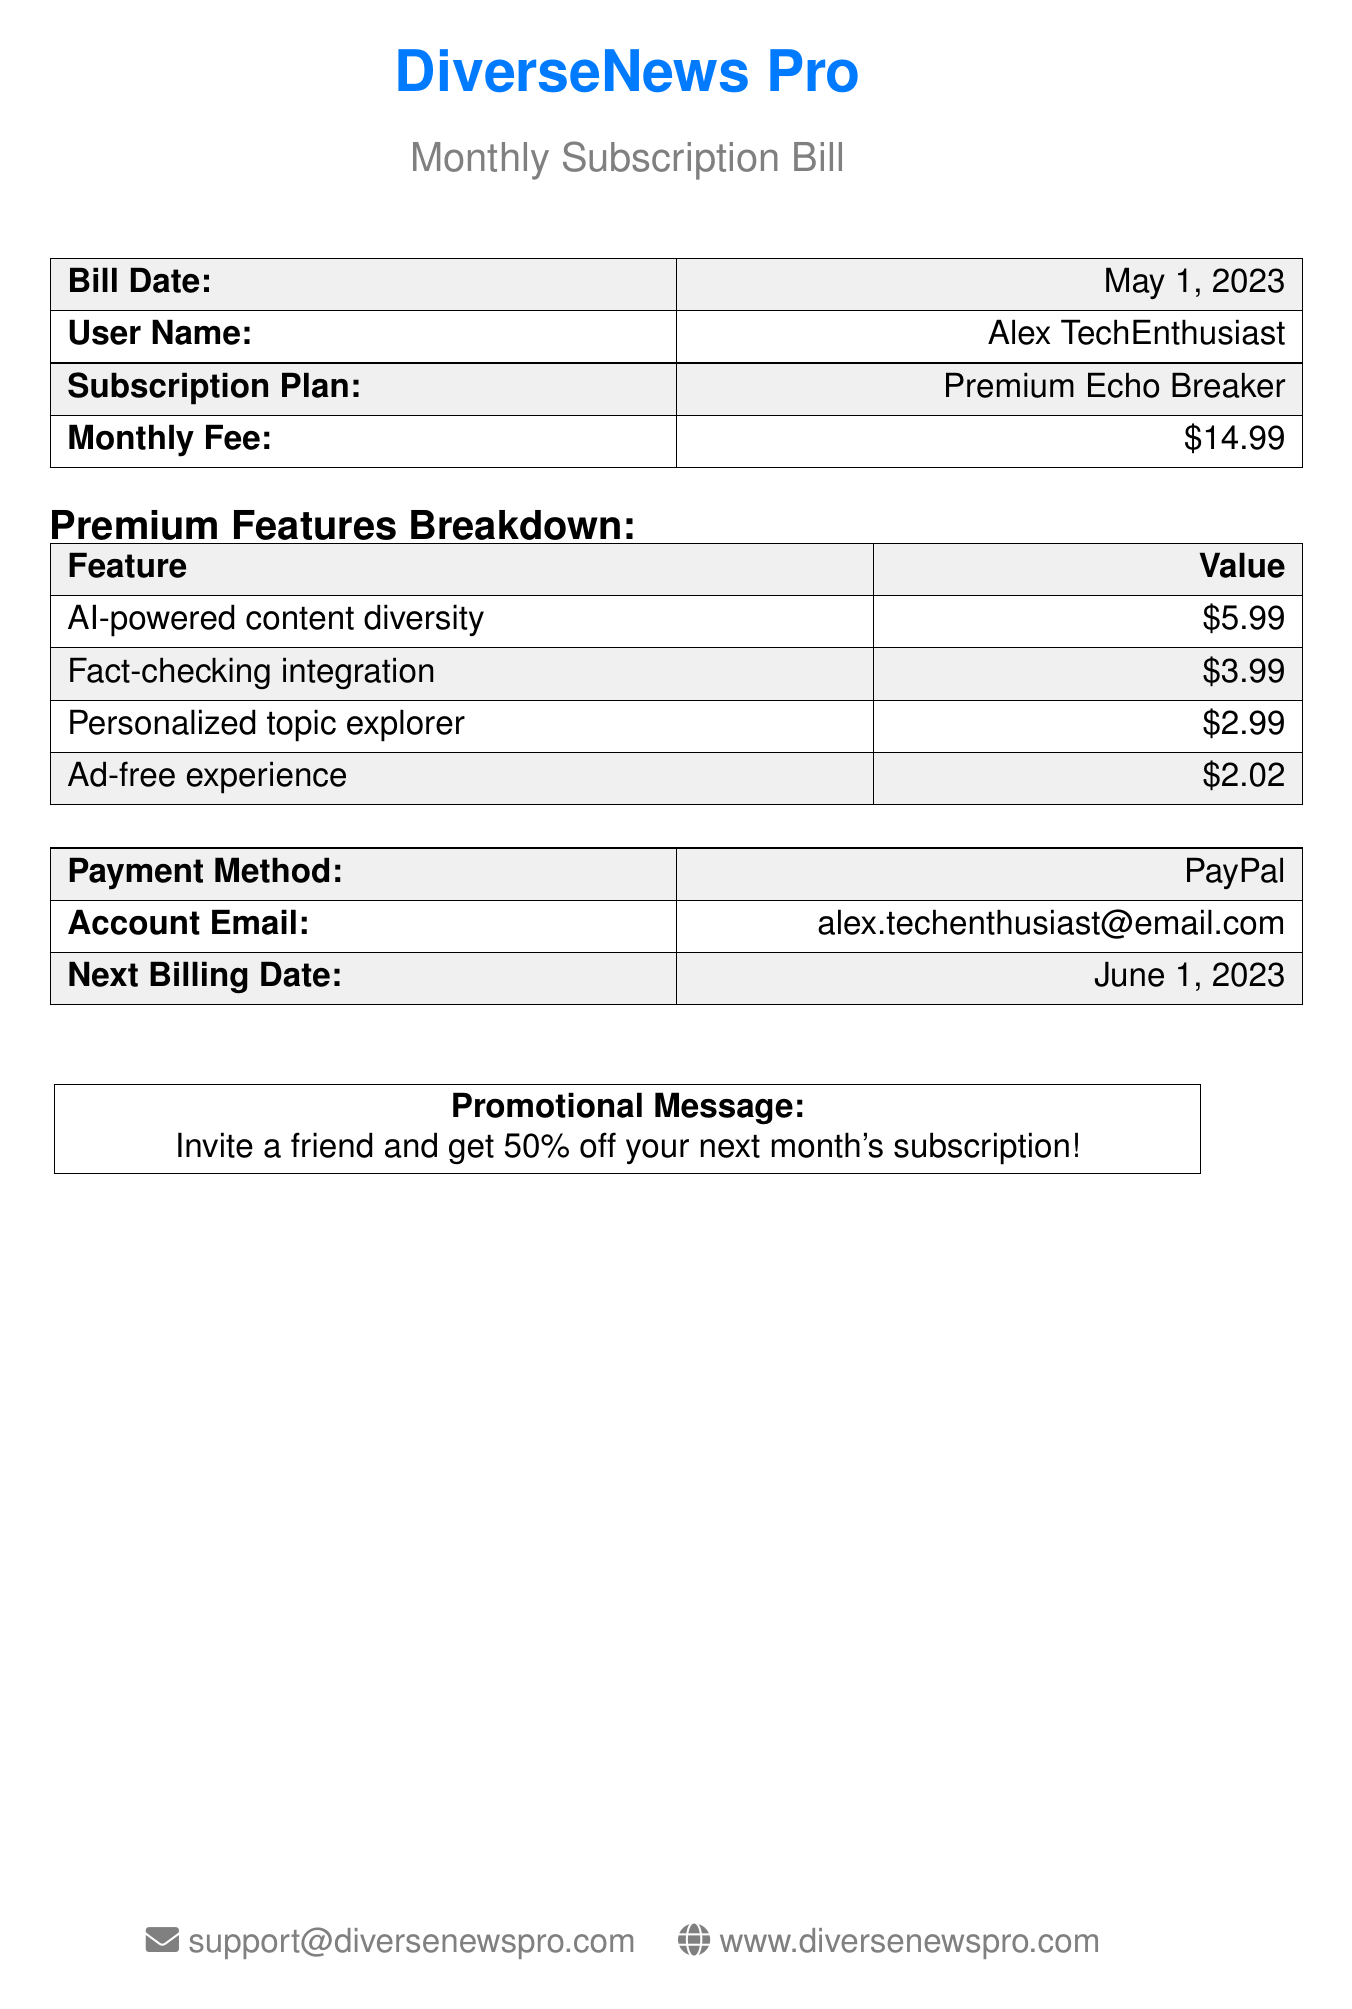What is the bill date? The bill date is stated in the document, which is May 1, 2023.
Answer: May 1, 2023 What is the subscription plan? The subscription plan is detailed in the document, identified as Premium Echo Breaker.
Answer: Premium Echo Breaker How much is the monthly fee? The monthly fee can be found in the document, listed as $14.99.
Answer: $14.99 What is the total value of premium features? The total value is the sum of all premium features, which adds up to $14.99.
Answer: $14.99 What payment method is used? The document specifies the payment method as PayPal.
Answer: PayPal What is the next billing date? The next billing date can be found in the document and is stated as June 1, 2023.
Answer: June 1, 2023 What feature has the highest individual value? The feature with the highest value is AI-powered content diversity according to the premium features breakdown.
Answer: AI-powered content diversity What promotional offer is mentioned? The document contains a promotional message offering a 50% discount for inviting a friend.
Answer: 50% off How can support be contacted? Contact details for support are provided in the document, which lists an email address.
Answer: support@diversenewspro.com 